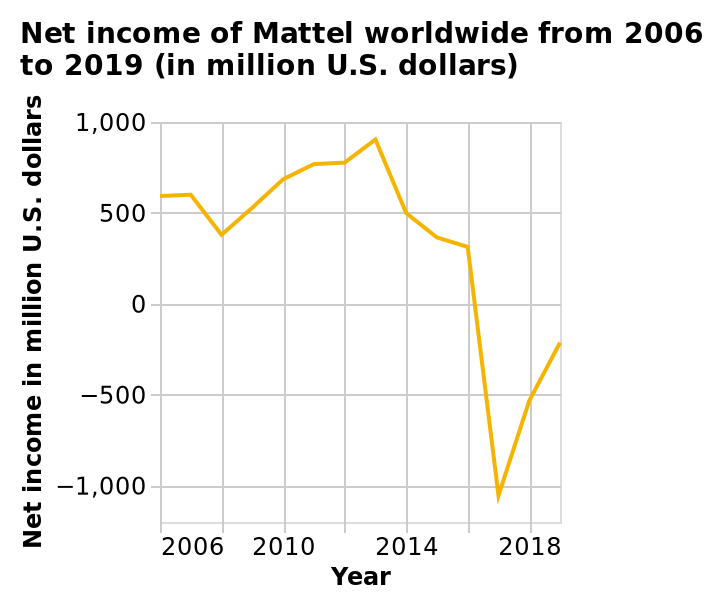<image>
please summary the statistics and relations of the chart Mattel's worldwide net income in million U.S. dollars dropped slightly in 2005 before seeing a steady rise between 2006 and 2012, then rising sharply between 2012 and 2013. Following this, Mattel reported a sharp decline between 2013 and 2014, before starting to stabalise between 2014 and 2016. A dramatic, steep decline followed between 2016 and approximately 2017, with the company seeing it's lowest net revenue for a fiscal year in a decade. Fortunately, Mattel's earnings have recovered through 2018, with it likely to hit positive again based on the upward trend in revenue. What does the y-axis represent in the line plot?  The y-axis represents the Net income in million U.S. dollars. Has Mattel's earnings recovered in recent years? Yes, Mattel's earnings have recovered through 2018, with the company expected to hit positive again based on the upward trend in revenue. 